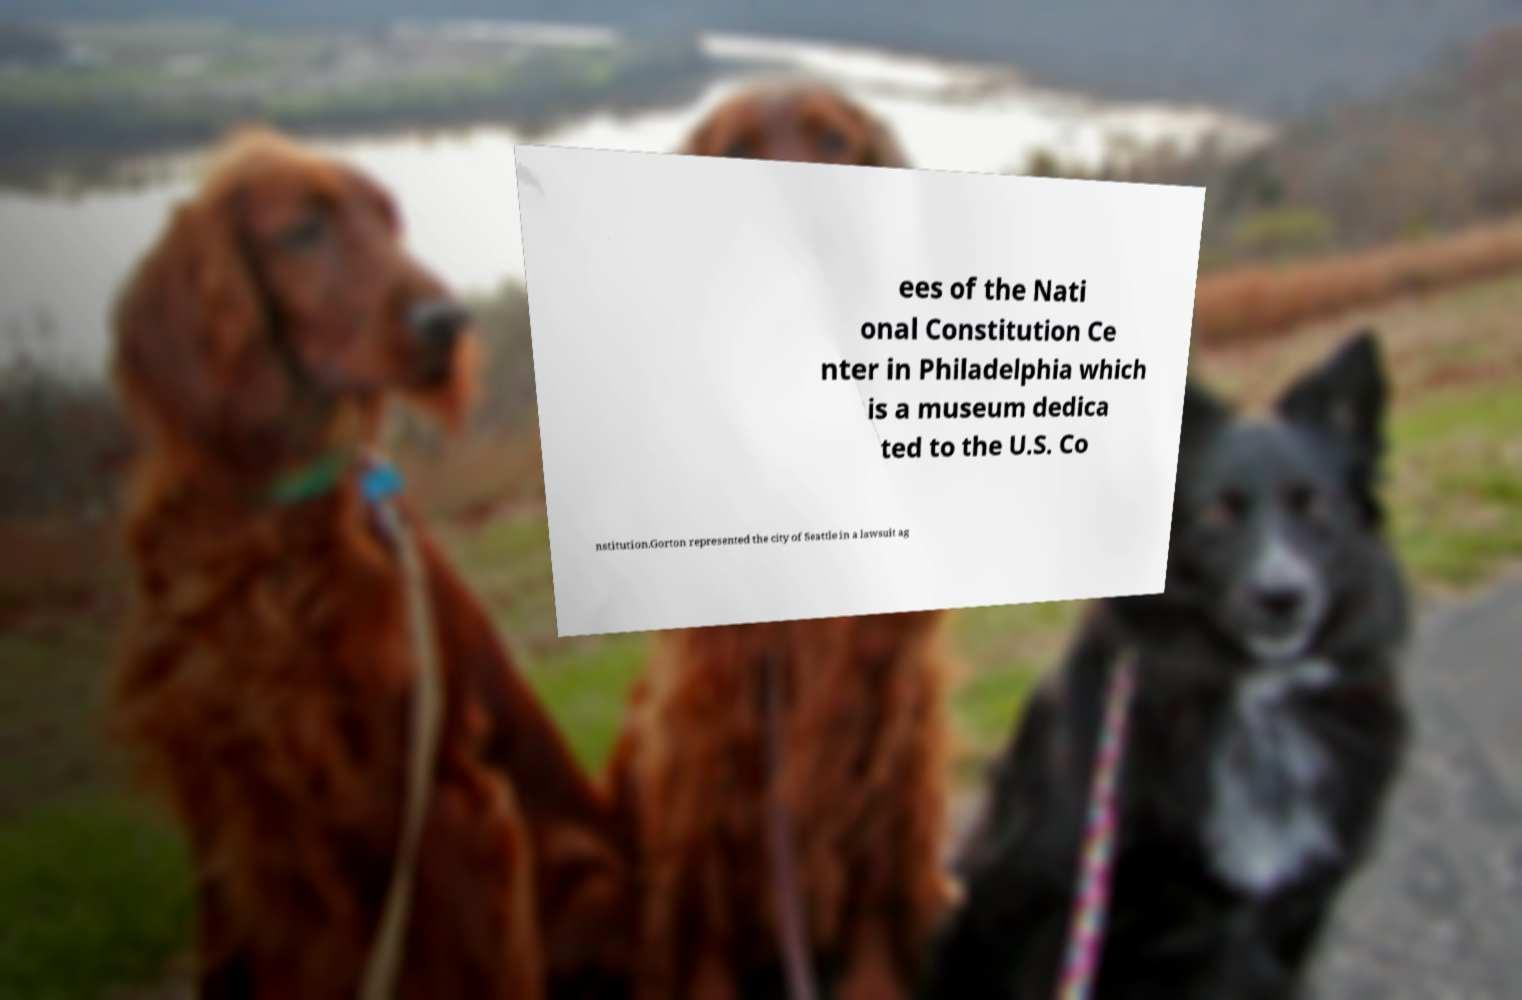I need the written content from this picture converted into text. Can you do that? ees of the Nati onal Constitution Ce nter in Philadelphia which is a museum dedica ted to the U.S. Co nstitution.Gorton represented the city of Seattle in a lawsuit ag 